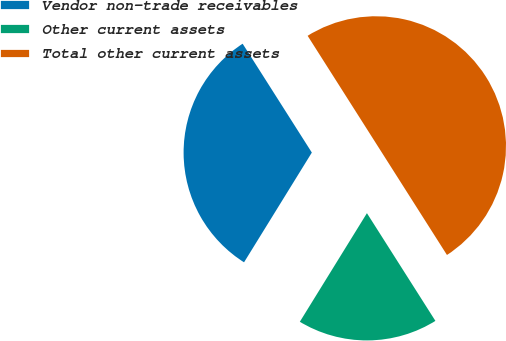Convert chart to OTSL. <chart><loc_0><loc_0><loc_500><loc_500><pie_chart><fcel>Vendor non-trade receivables<fcel>Other current assets<fcel>Total other current assets<nl><fcel>32.18%<fcel>17.82%<fcel>50.0%<nl></chart> 